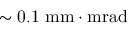<formula> <loc_0><loc_0><loc_500><loc_500>\sim 0 . 1 \ m m \cdot m r a d</formula> 